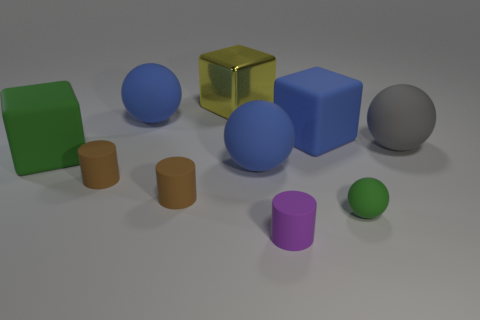Subtract all blocks. How many objects are left? 7 Subtract all large gray matte things. Subtract all spheres. How many objects are left? 5 Add 8 blue matte blocks. How many blue matte blocks are left? 9 Add 8 red metallic objects. How many red metallic objects exist? 8 Subtract 0 red cubes. How many objects are left? 10 